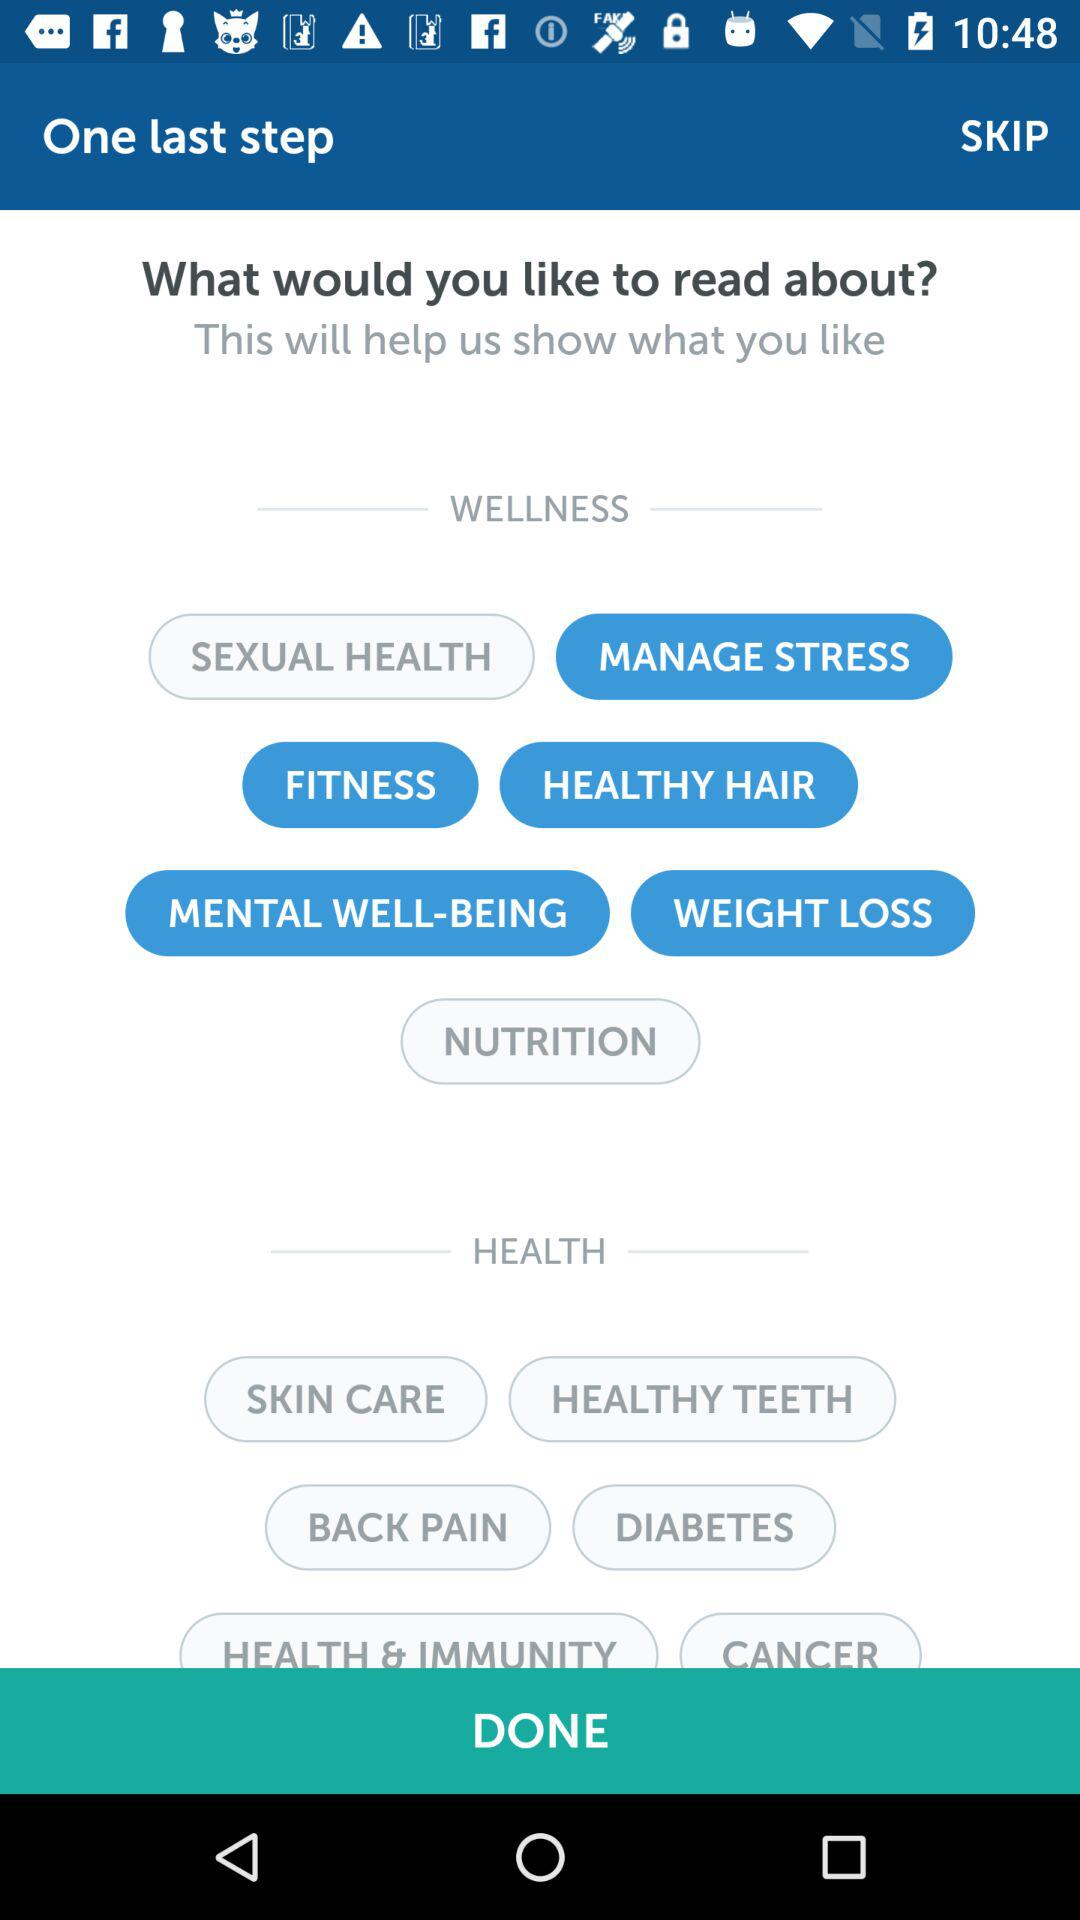How many wellness topics are there?
Answer the question using a single word or phrase. 7 